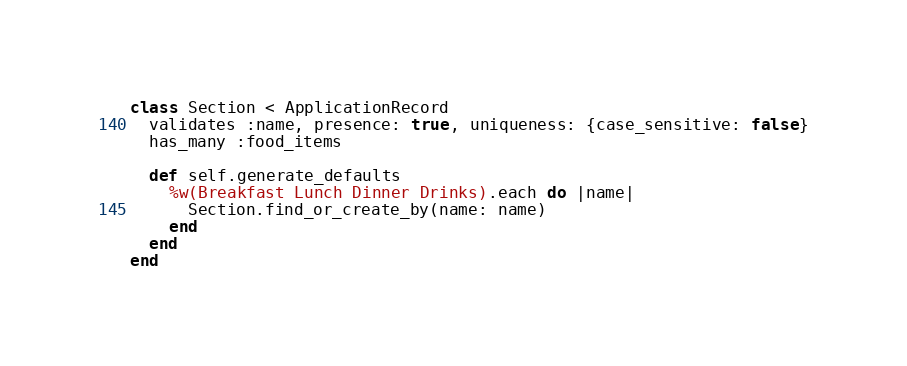Convert code to text. <code><loc_0><loc_0><loc_500><loc_500><_Ruby_>class Section < ApplicationRecord
  validates :name, presence: true, uniqueness: {case_sensitive: false}
  has_many :food_items

  def self.generate_defaults
    %w(Breakfast Lunch Dinner Drinks).each do |name|
      Section.find_or_create_by(name: name)
    end
  end
end
</code> 